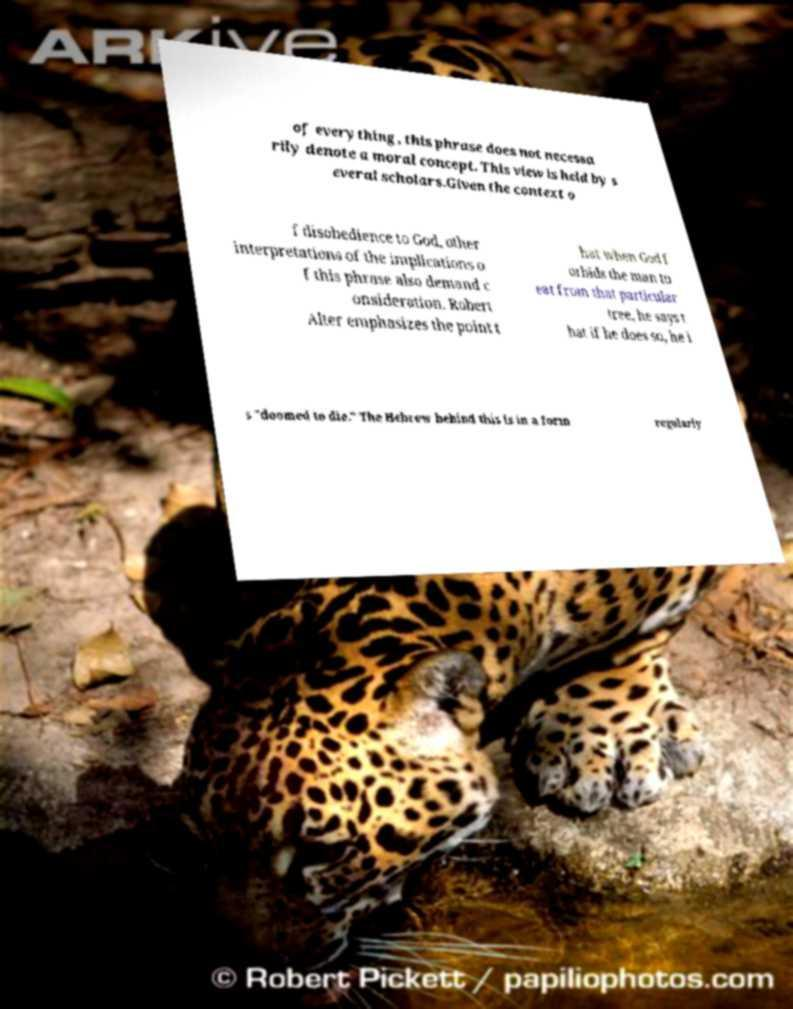Please identify and transcribe the text found in this image. of everything, this phrase does not necessa rily denote a moral concept. This view is held by s everal scholars.Given the context o f disobedience to God, other interpretations of the implications o f this phrase also demand c onsideration. Robert Alter emphasizes the point t hat when God f orbids the man to eat from that particular tree, he says t hat if he does so, he i s "doomed to die." The Hebrew behind this is in a form regularly 